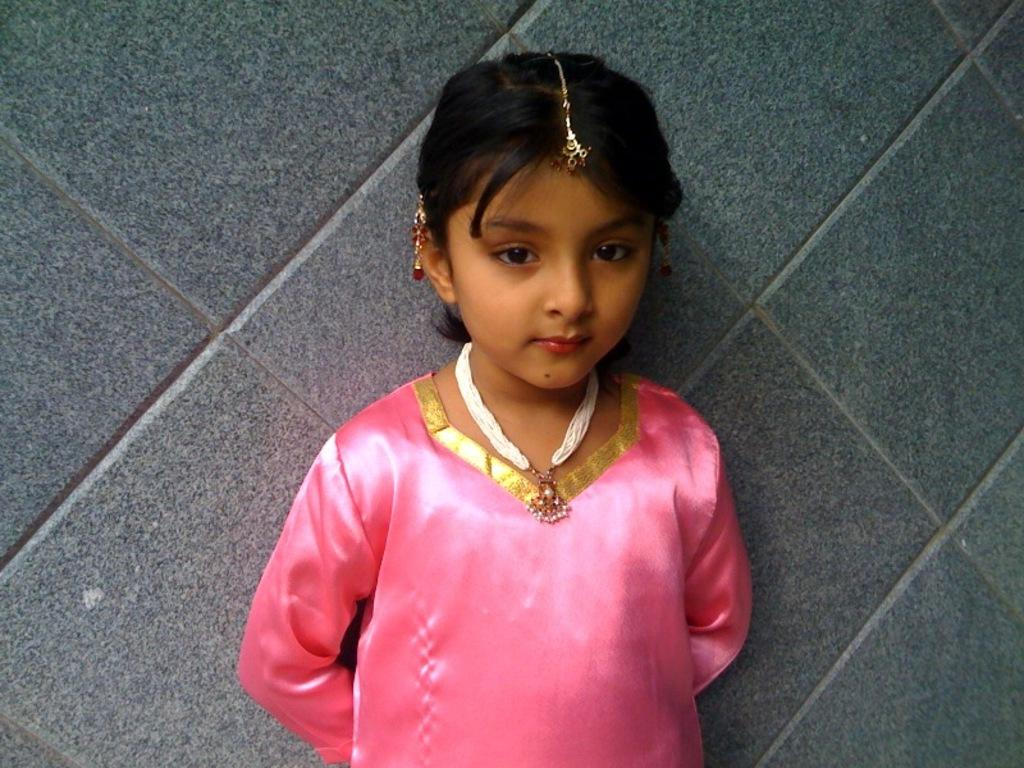Who is the main subject in the picture? There is a girl in the picture. What is the girl's location in the image? The girl is standing in front of a wall. What is the girl wearing in the picture? The girl is wearing jewelry and a pink dress. What type of beast can be seen interacting with the girl in the image? There is no beast present in the image; it features a girl standing in front of a wall. What type of fire is visible in the image? There is no fire present in the image. 